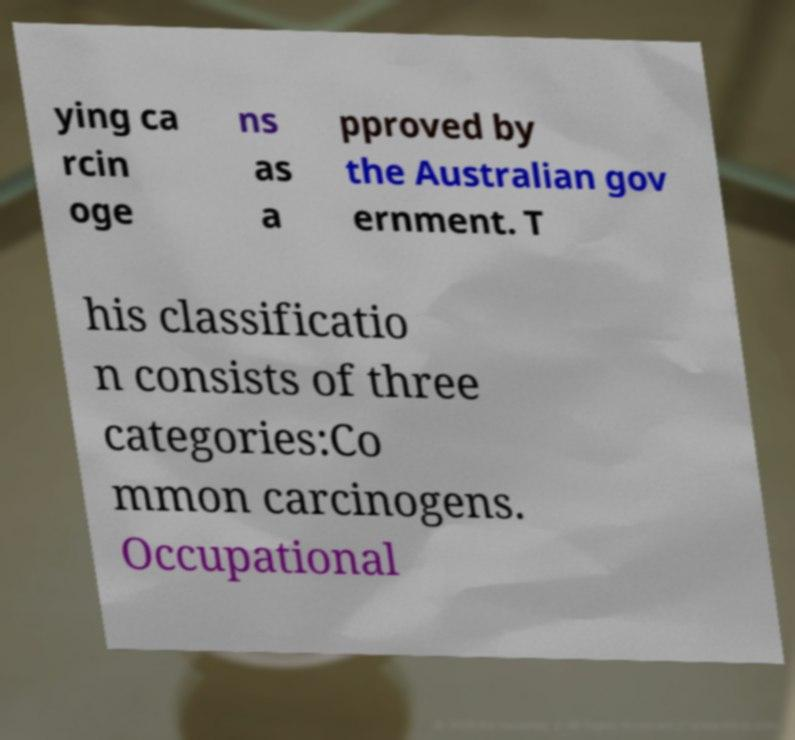Can you read and provide the text displayed in the image?This photo seems to have some interesting text. Can you extract and type it out for me? ying ca rcin oge ns as a pproved by the Australian gov ernment. T his classificatio n consists of three categories:Co mmon carcinogens. Occupational 